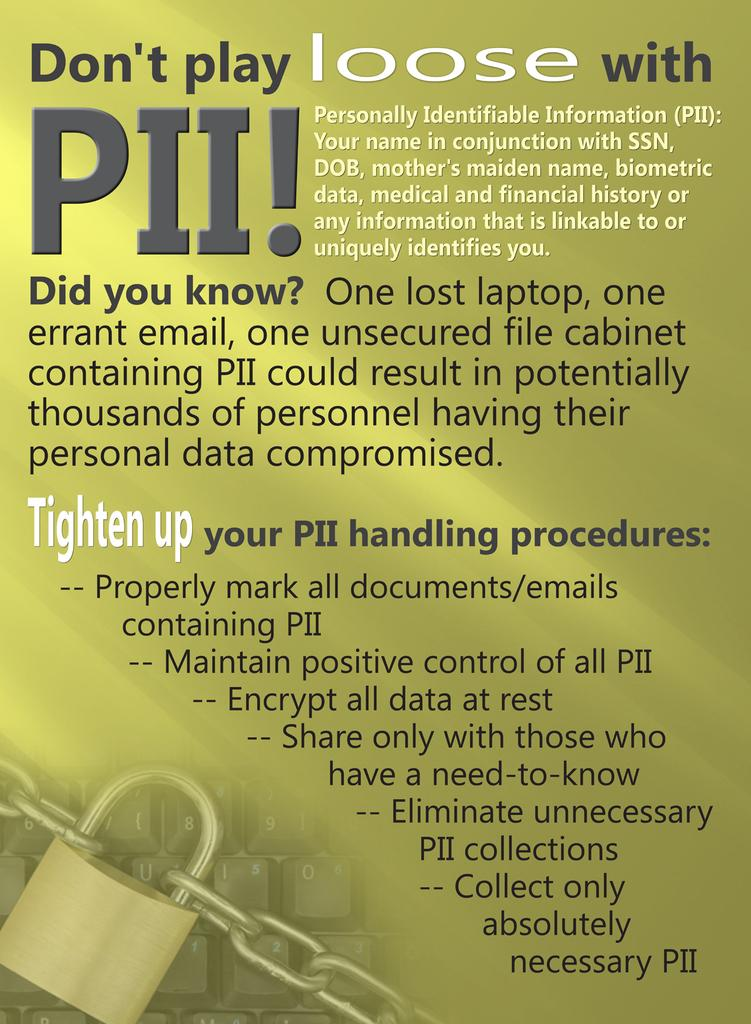<image>
Share a concise interpretation of the image provided. A flyer that states Don't Play loose with PII! 